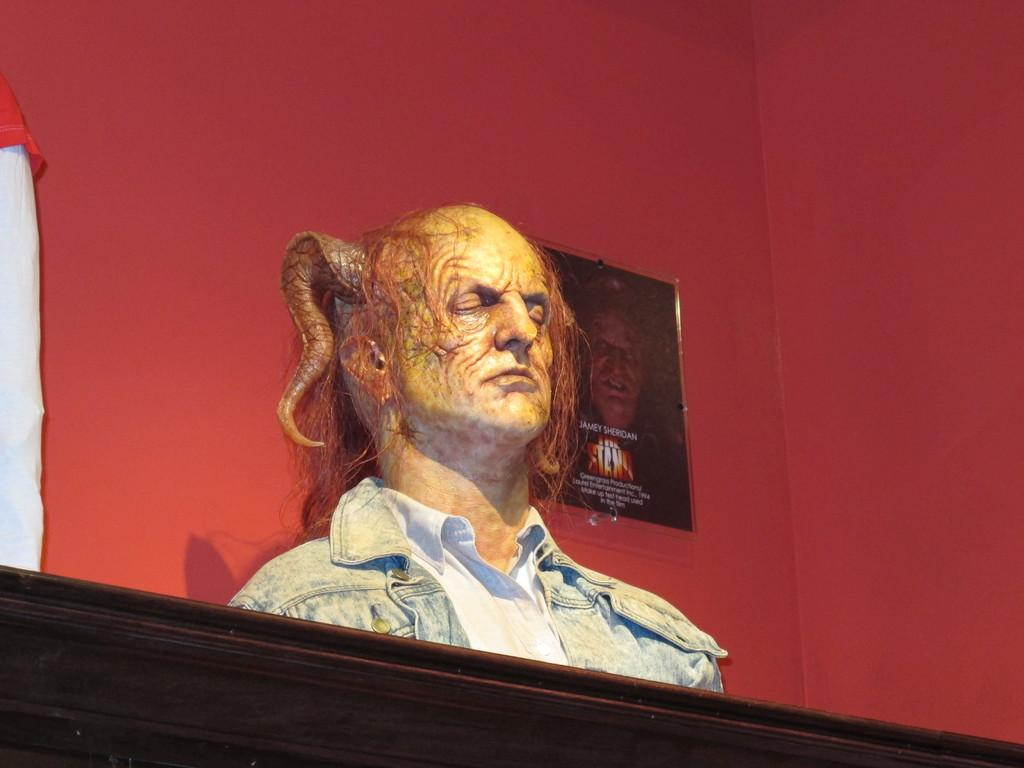What is the main subject of the image? There is a statue in the image. Can you describe the statue? The statue is of a man with a horn on its head. Where is the statue placed? The statue is placed on a wooden rafter. What can be seen in the background of the image? There is a red color wall in the background. Are there any other objects or features on the red wall? Yes, there is a hanging photo frame on the red wall. What sound does the chicken make in the image? There is no chicken present in the image, so it is not possible to determine the sound it might make. 